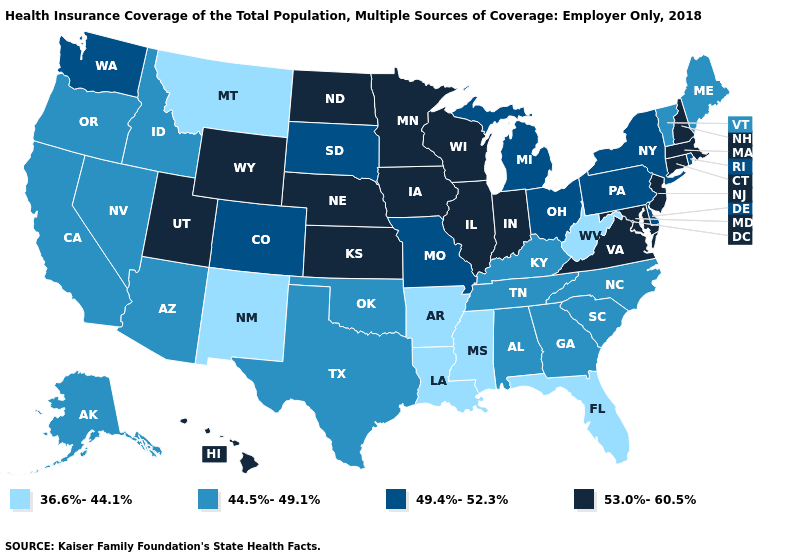Name the states that have a value in the range 53.0%-60.5%?
Write a very short answer. Connecticut, Hawaii, Illinois, Indiana, Iowa, Kansas, Maryland, Massachusetts, Minnesota, Nebraska, New Hampshire, New Jersey, North Dakota, Utah, Virginia, Wisconsin, Wyoming. Name the states that have a value in the range 44.5%-49.1%?
Quick response, please. Alabama, Alaska, Arizona, California, Georgia, Idaho, Kentucky, Maine, Nevada, North Carolina, Oklahoma, Oregon, South Carolina, Tennessee, Texas, Vermont. Name the states that have a value in the range 53.0%-60.5%?
Concise answer only. Connecticut, Hawaii, Illinois, Indiana, Iowa, Kansas, Maryland, Massachusetts, Minnesota, Nebraska, New Hampshire, New Jersey, North Dakota, Utah, Virginia, Wisconsin, Wyoming. Does Mississippi have the lowest value in the USA?
Write a very short answer. Yes. Name the states that have a value in the range 53.0%-60.5%?
Answer briefly. Connecticut, Hawaii, Illinois, Indiana, Iowa, Kansas, Maryland, Massachusetts, Minnesota, Nebraska, New Hampshire, New Jersey, North Dakota, Utah, Virginia, Wisconsin, Wyoming. Does Utah have the highest value in the West?
Keep it brief. Yes. What is the value of Connecticut?
Be succinct. 53.0%-60.5%. Does Wisconsin have the lowest value in the MidWest?
Be succinct. No. What is the value of Arkansas?
Keep it brief. 36.6%-44.1%. Which states hav the highest value in the West?
Keep it brief. Hawaii, Utah, Wyoming. Which states have the highest value in the USA?
Quick response, please. Connecticut, Hawaii, Illinois, Indiana, Iowa, Kansas, Maryland, Massachusetts, Minnesota, Nebraska, New Hampshire, New Jersey, North Dakota, Utah, Virginia, Wisconsin, Wyoming. What is the lowest value in the South?
Short answer required. 36.6%-44.1%. Name the states that have a value in the range 36.6%-44.1%?
Answer briefly. Arkansas, Florida, Louisiana, Mississippi, Montana, New Mexico, West Virginia. Which states have the lowest value in the Northeast?
Give a very brief answer. Maine, Vermont. Does Missouri have a lower value than Massachusetts?
Give a very brief answer. Yes. 